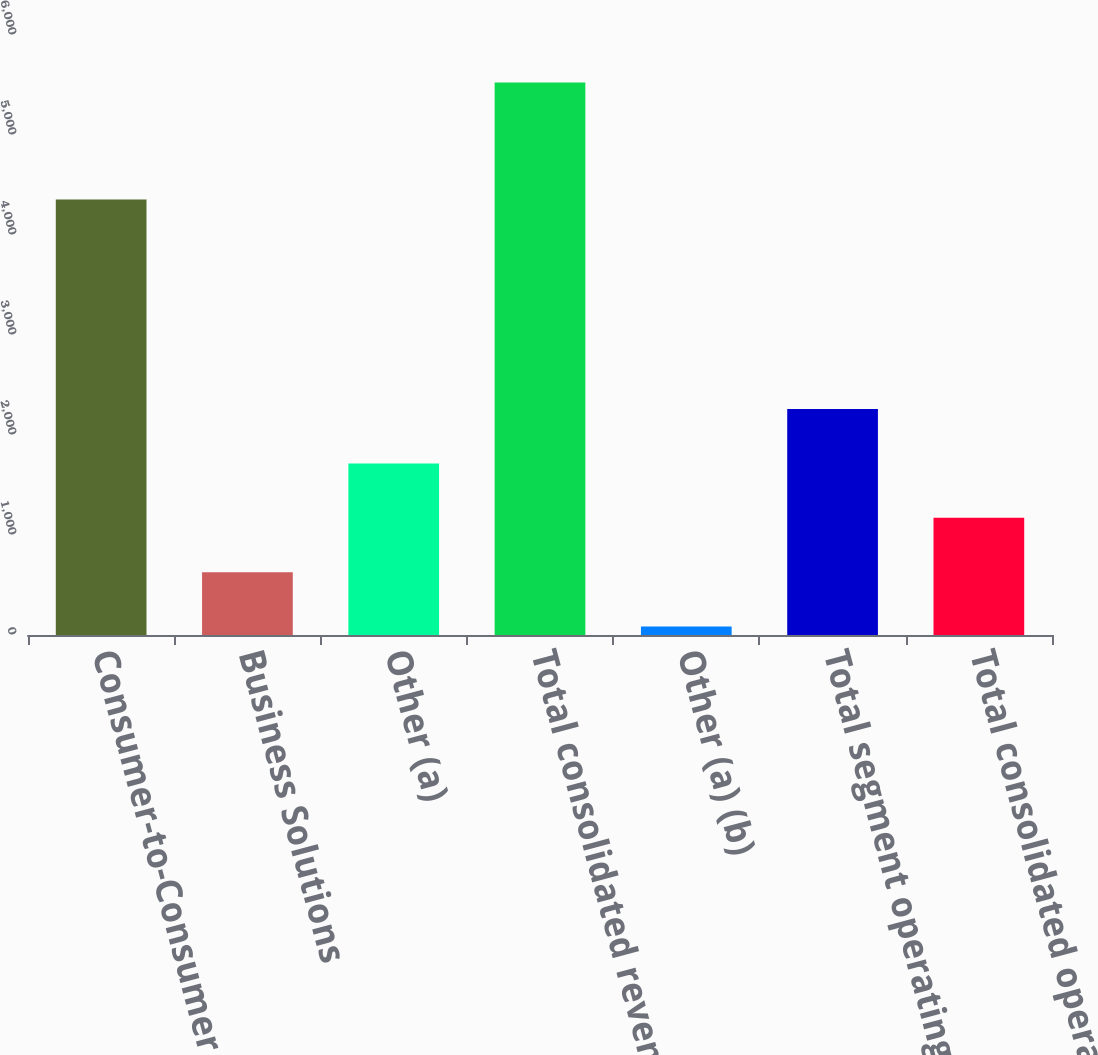Convert chart. <chart><loc_0><loc_0><loc_500><loc_500><bar_chart><fcel>Consumer-to-Consumer<fcel>Business Solutions<fcel>Other (a)<fcel>Total consolidated revenues<fcel>Other (a) (b)<fcel>Total segment operating income<fcel>Total consolidated operating<nl><fcel>4354.5<fcel>627.85<fcel>1715.95<fcel>5524.3<fcel>83.8<fcel>2260<fcel>1171.9<nl></chart> 